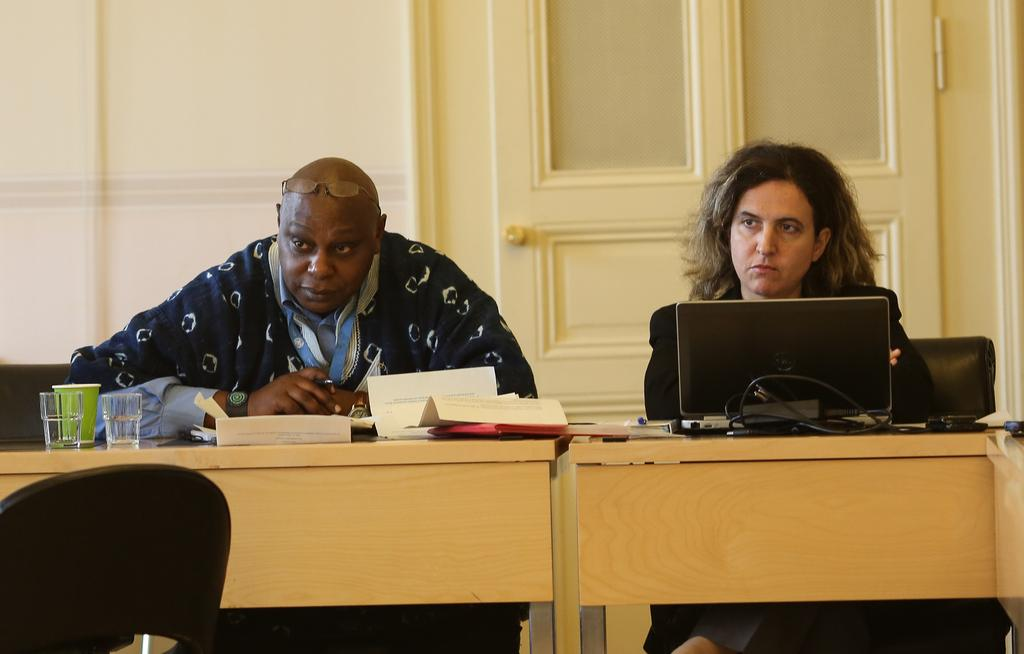How many people are sitting on the chair in the image? There are two persons sitting on a chair in the image. What is in front of the two persons? There is a table in front of the two persons. What electronic device can be seen on the table? There is a laptop on the table. What else is present on the table besides the laptop? There is a cable, papers, and glasses on the table. What type of decision can be seen in the middle of the image? There is no decision visible in the image; it features two persons sitting on a chair, a table with various items, and a laptop. Are there any balloons present in the image? No, there are no balloons present in the image. 